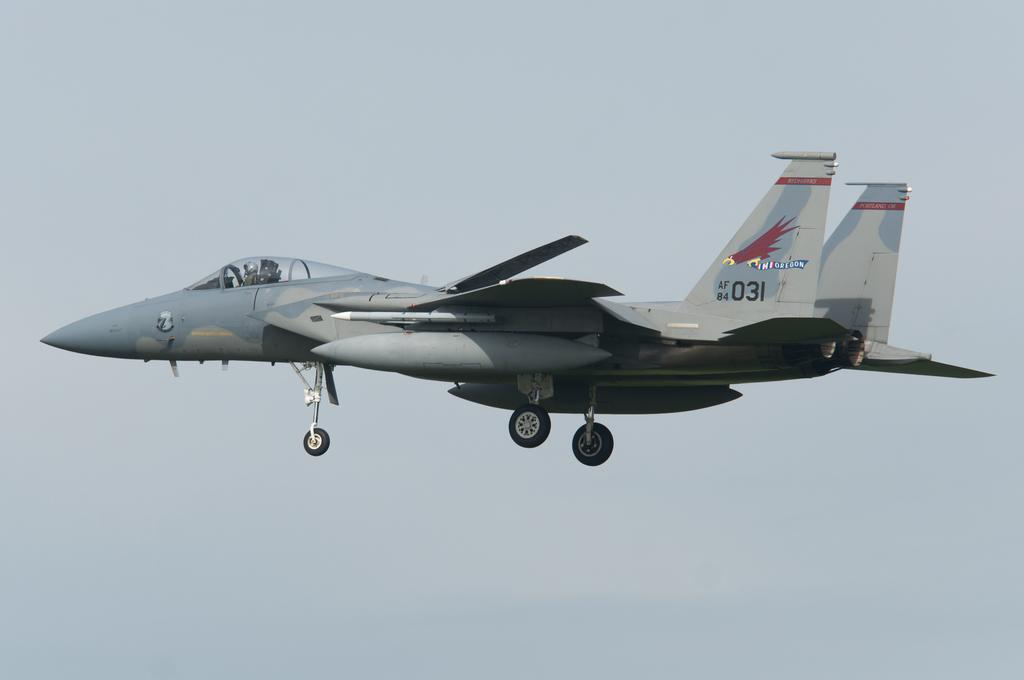<image>
Offer a succinct explanation of the picture presented. the jet with the Oregon painting on its tail is flying through the sky 